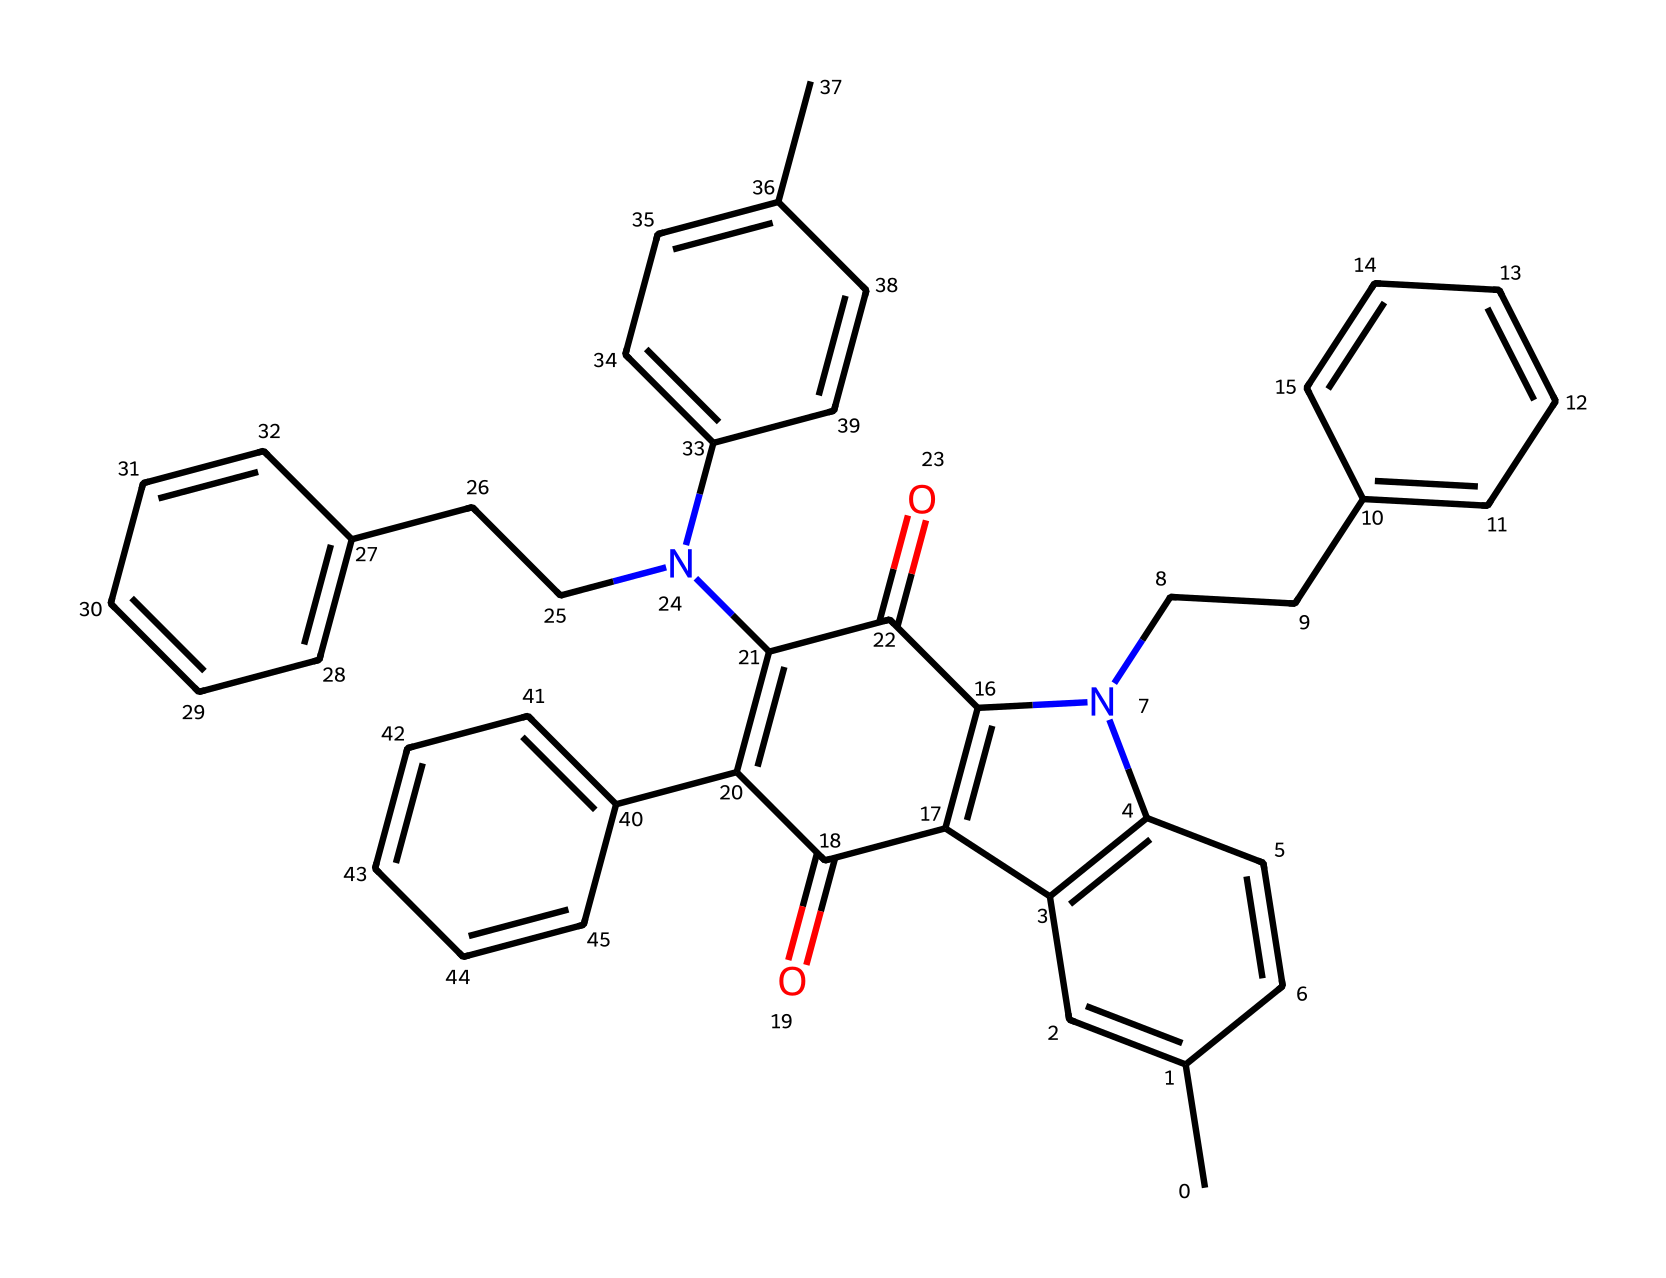What is the main functional group present in this chemical? The presence of nitrogen atoms indicates that there are amine or amide functional groups, often associated with biological activity. Since the structure shows carbonyl groups attached to the nitrogen, it implies the presence of amides.
Answer: amide How many rings are present in the molecular structure? By carefully analyzing the SMILES representation, we can identify multiple closed loops in the structure. Counting these, we find there are four distinct rings present.
Answer: four What type of chemical compounds are represented by this structure? Given its complex aromatic nature and the nitrogen atoms, this compound is classified as an organic pigment, often utilized in coloration and inks.
Answer: organic pigment What is the approximate weight of the entire molecule in grams per mole? To find the molecular weight, one would sum the atomic weights of all constituent atoms indicated by the SMILES notation. Calculating this gives an approximate weight near 500 grams per mole.
Answer: 500 grams per mole Is this chemical soluble in water? Generally, the presence of multiple aromatic systems and hydrophobic parts suggests that this chemical is not very soluble in water, as polar solvents typically do not dissolve large non-polar organic compounds.
Answer: not soluble How many nitrogen atoms are present in this molecule? In the provided structure, there are two distinct nitrogen atoms included, which can be counted directly in the SMILES representation.
Answer: two 